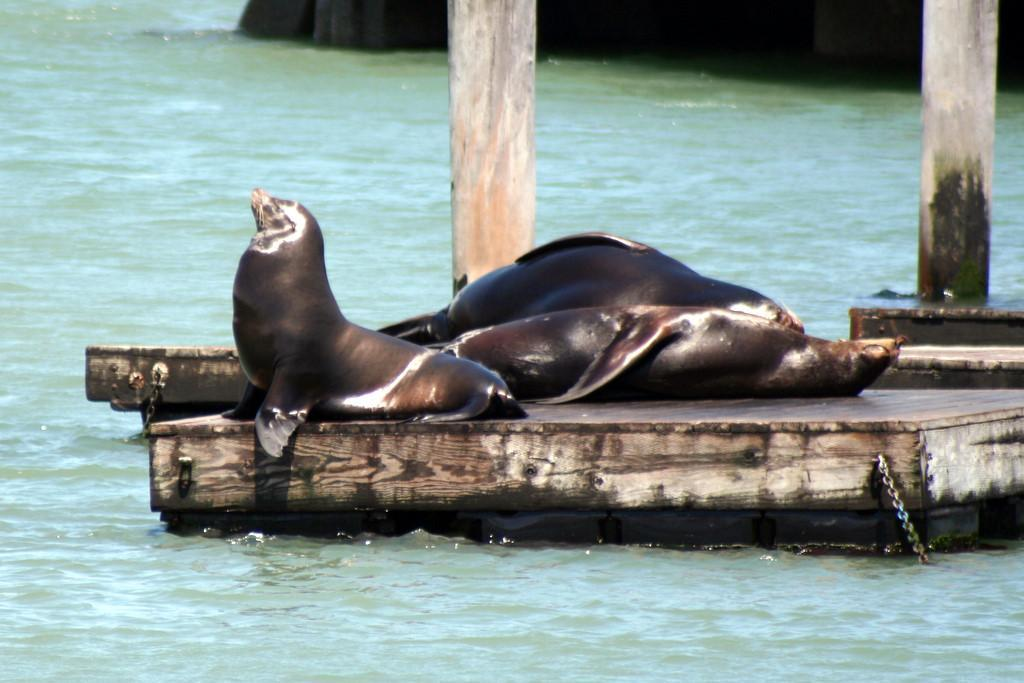What animals can be seen in the image? There are seals in the image. Where are the seals located? The seals are on a wooden bridge. What can be seen at the bottom of the image? There is water visible at the bottom of the image. What type of toys can be seen in the image? There are no toys present in the image; it features seals on a wooden bridge with water visible at the bottom. 